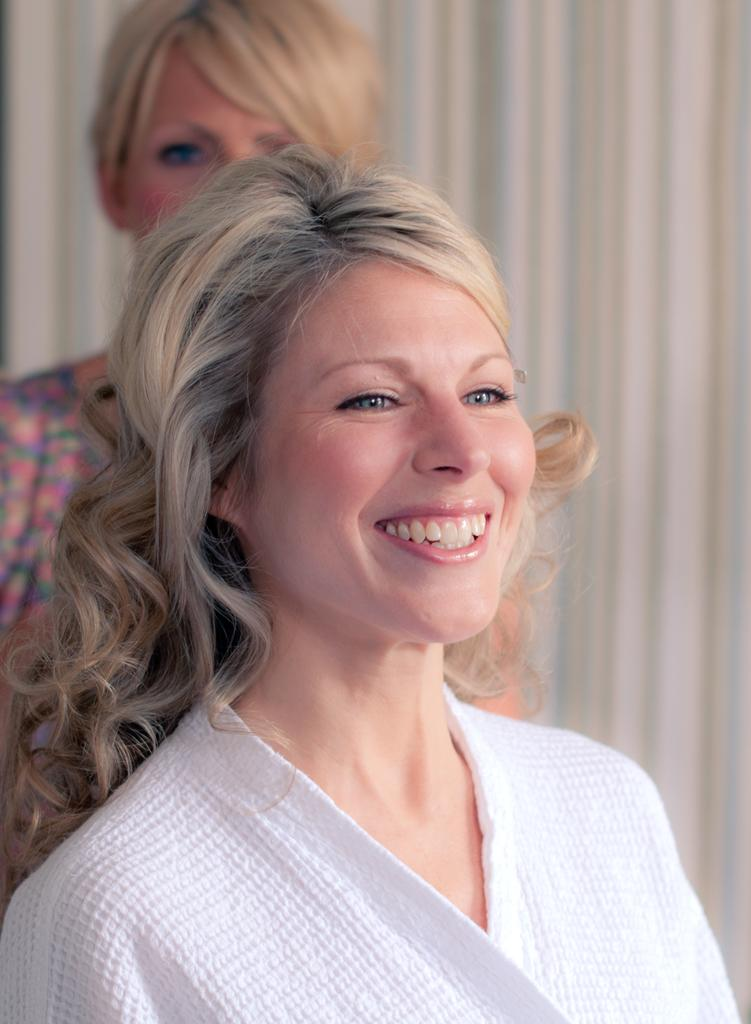What is the woman in the foreground of the image doing? The woman in the foreground of the image is standing and smiling. Can you describe the woman in the background of the image? There is another woman standing in the background of the image. What type of hole can be seen on the woman's face in the image? There is no hole visible on the woman's face in the image. Does the woman in the foreground have a pet with her in the image? There is no pet visible in the image. 